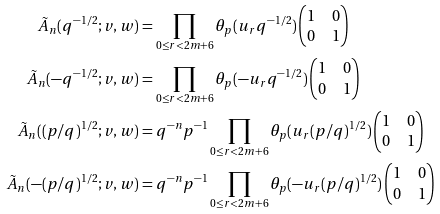<formula> <loc_0><loc_0><loc_500><loc_500>\tilde { A } _ { n } ( q ^ { - 1 / 2 } ; v , w ) & = \prod _ { 0 \leq r < 2 m + 6 } \theta _ { p } ( u _ { r } q ^ { - 1 / 2 } ) \begin{pmatrix} 1 & 0 \\ 0 & 1 \end{pmatrix} \\ \tilde { A } _ { n } ( - q ^ { - 1 / 2 } ; v , w ) & = \prod _ { 0 \leq r < 2 m + 6 } \theta _ { p } ( - u _ { r } q ^ { - 1 / 2 } ) \begin{pmatrix} 1 & 0 \\ 0 & 1 \end{pmatrix} \\ \tilde { A } _ { n } ( ( p / q ) ^ { 1 / 2 } ; v , w ) & = q ^ { - n } p ^ { - 1 } \prod _ { 0 \leq r < 2 m + 6 } \theta _ { p } ( u _ { r } ( p / q ) ^ { 1 / 2 } ) \begin{pmatrix} 1 & 0 \\ 0 & 1 \end{pmatrix} \\ \tilde { A } _ { n } ( - ( p / q ) ^ { 1 / 2 } ; v , w ) & = q ^ { - n } p ^ { - 1 } \prod _ { 0 \leq r < 2 m + 6 } \theta _ { p } ( - u _ { r } ( p / q ) ^ { 1 / 2 } ) \begin{pmatrix} 1 & 0 \\ 0 & 1 \end{pmatrix}</formula> 